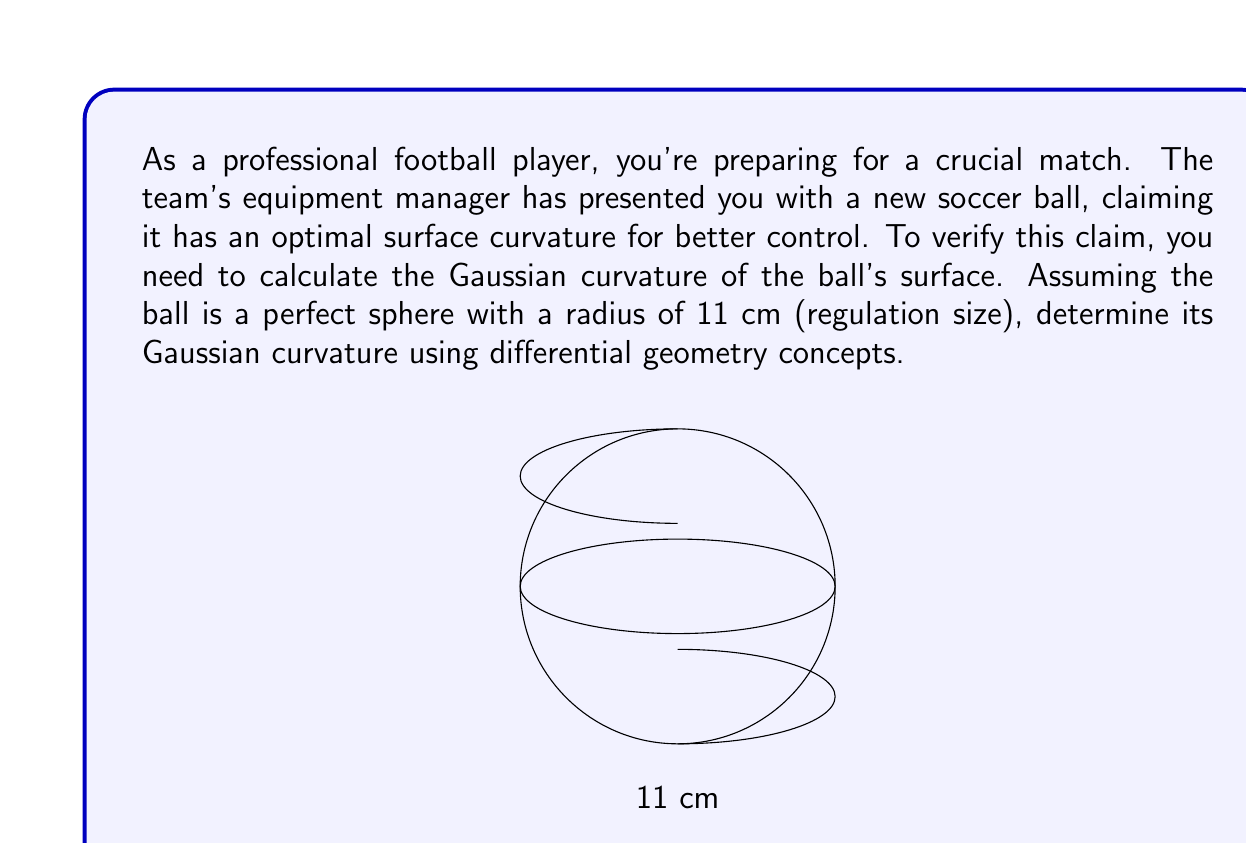Help me with this question. Let's approach this step-by-step:

1) In differential geometry, the Gaussian curvature (K) of a sphere is constant at every point on its surface and is given by:

   $$K = \frac{1}{R^2}$$

   where R is the radius of the sphere.

2) We're given that the radius of the soccer ball is 11 cm. Let's convert this to meters for standard units:

   $$R = 11 \text{ cm} = 0.11 \text{ m}$$

3) Now, we can substitute this value into our formula:

   $$K = \frac{1}{(0.11 \text{ m})^2}$$

4) Let's calculate this:

   $$K = \frac{1}{0.0121 \text{ m}^2} \approx 82.6446 \text{ m}^{-2}$$

5) This result means that at every point on the surface of the soccer ball, the Gaussian curvature is approximately 82.6446 per square meter.

6) In differential geometry, positive Gaussian curvature indicates that the surface is locally convex, which is consistent with the shape of a soccer ball.
Answer: $K \approx 82.6446 \text{ m}^{-2}$ 